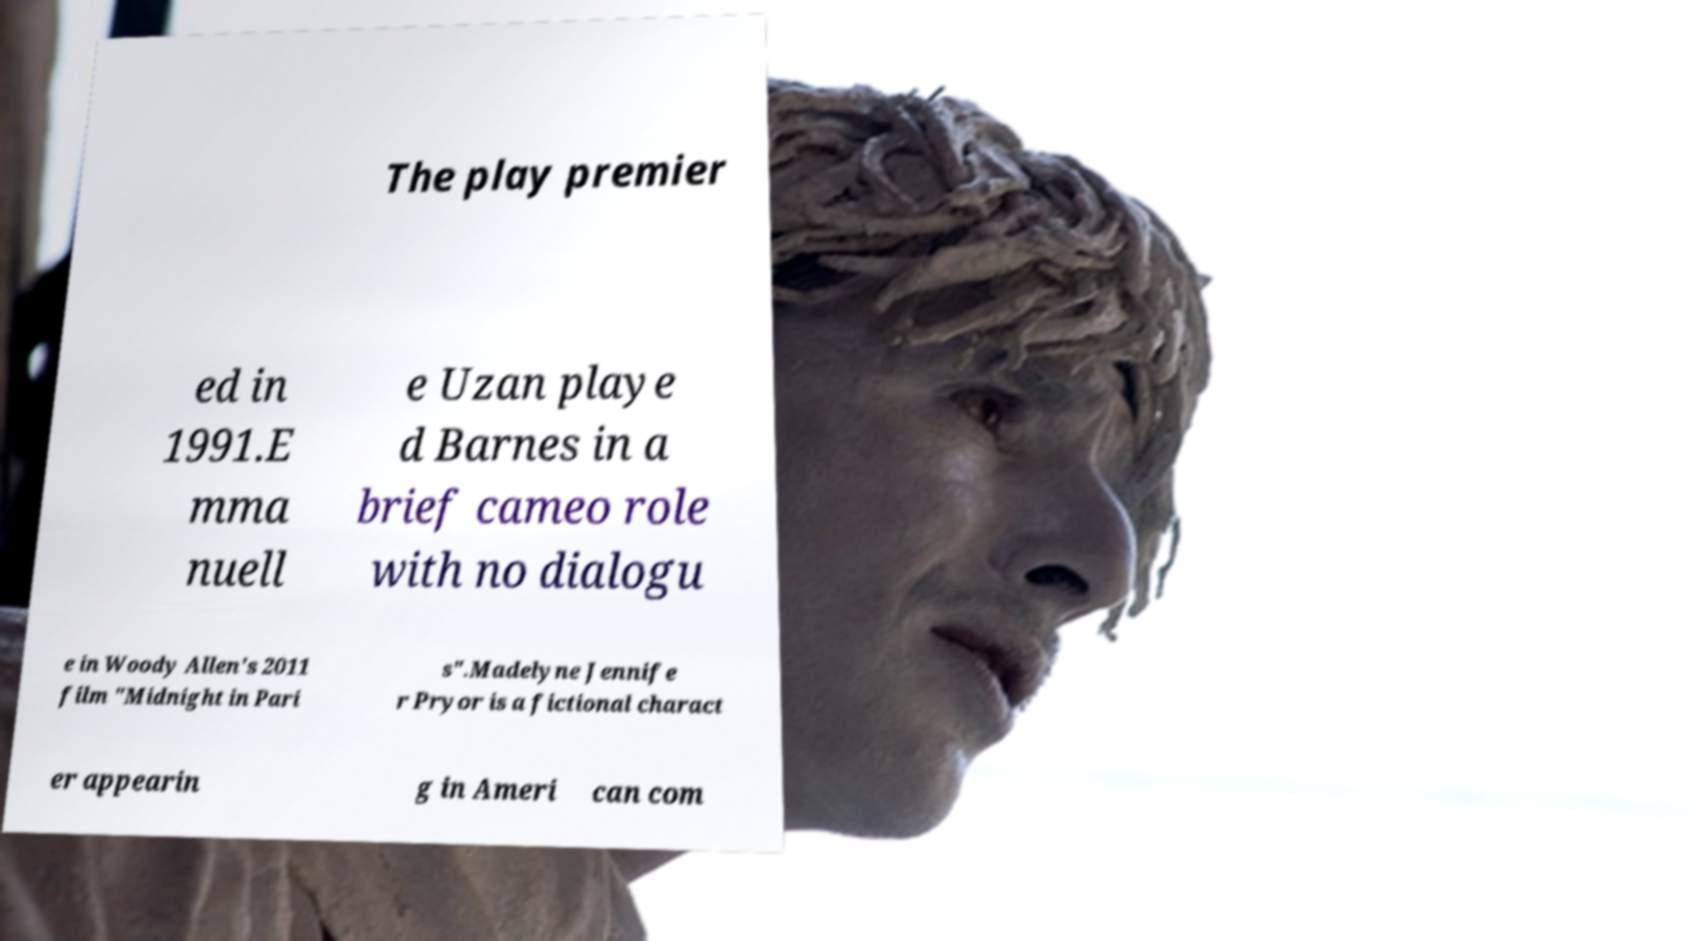Please identify and transcribe the text found in this image. The play premier ed in 1991.E mma nuell e Uzan playe d Barnes in a brief cameo role with no dialogu e in Woody Allen's 2011 film "Midnight in Pari s".Madelyne Jennife r Pryor is a fictional charact er appearin g in Ameri can com 